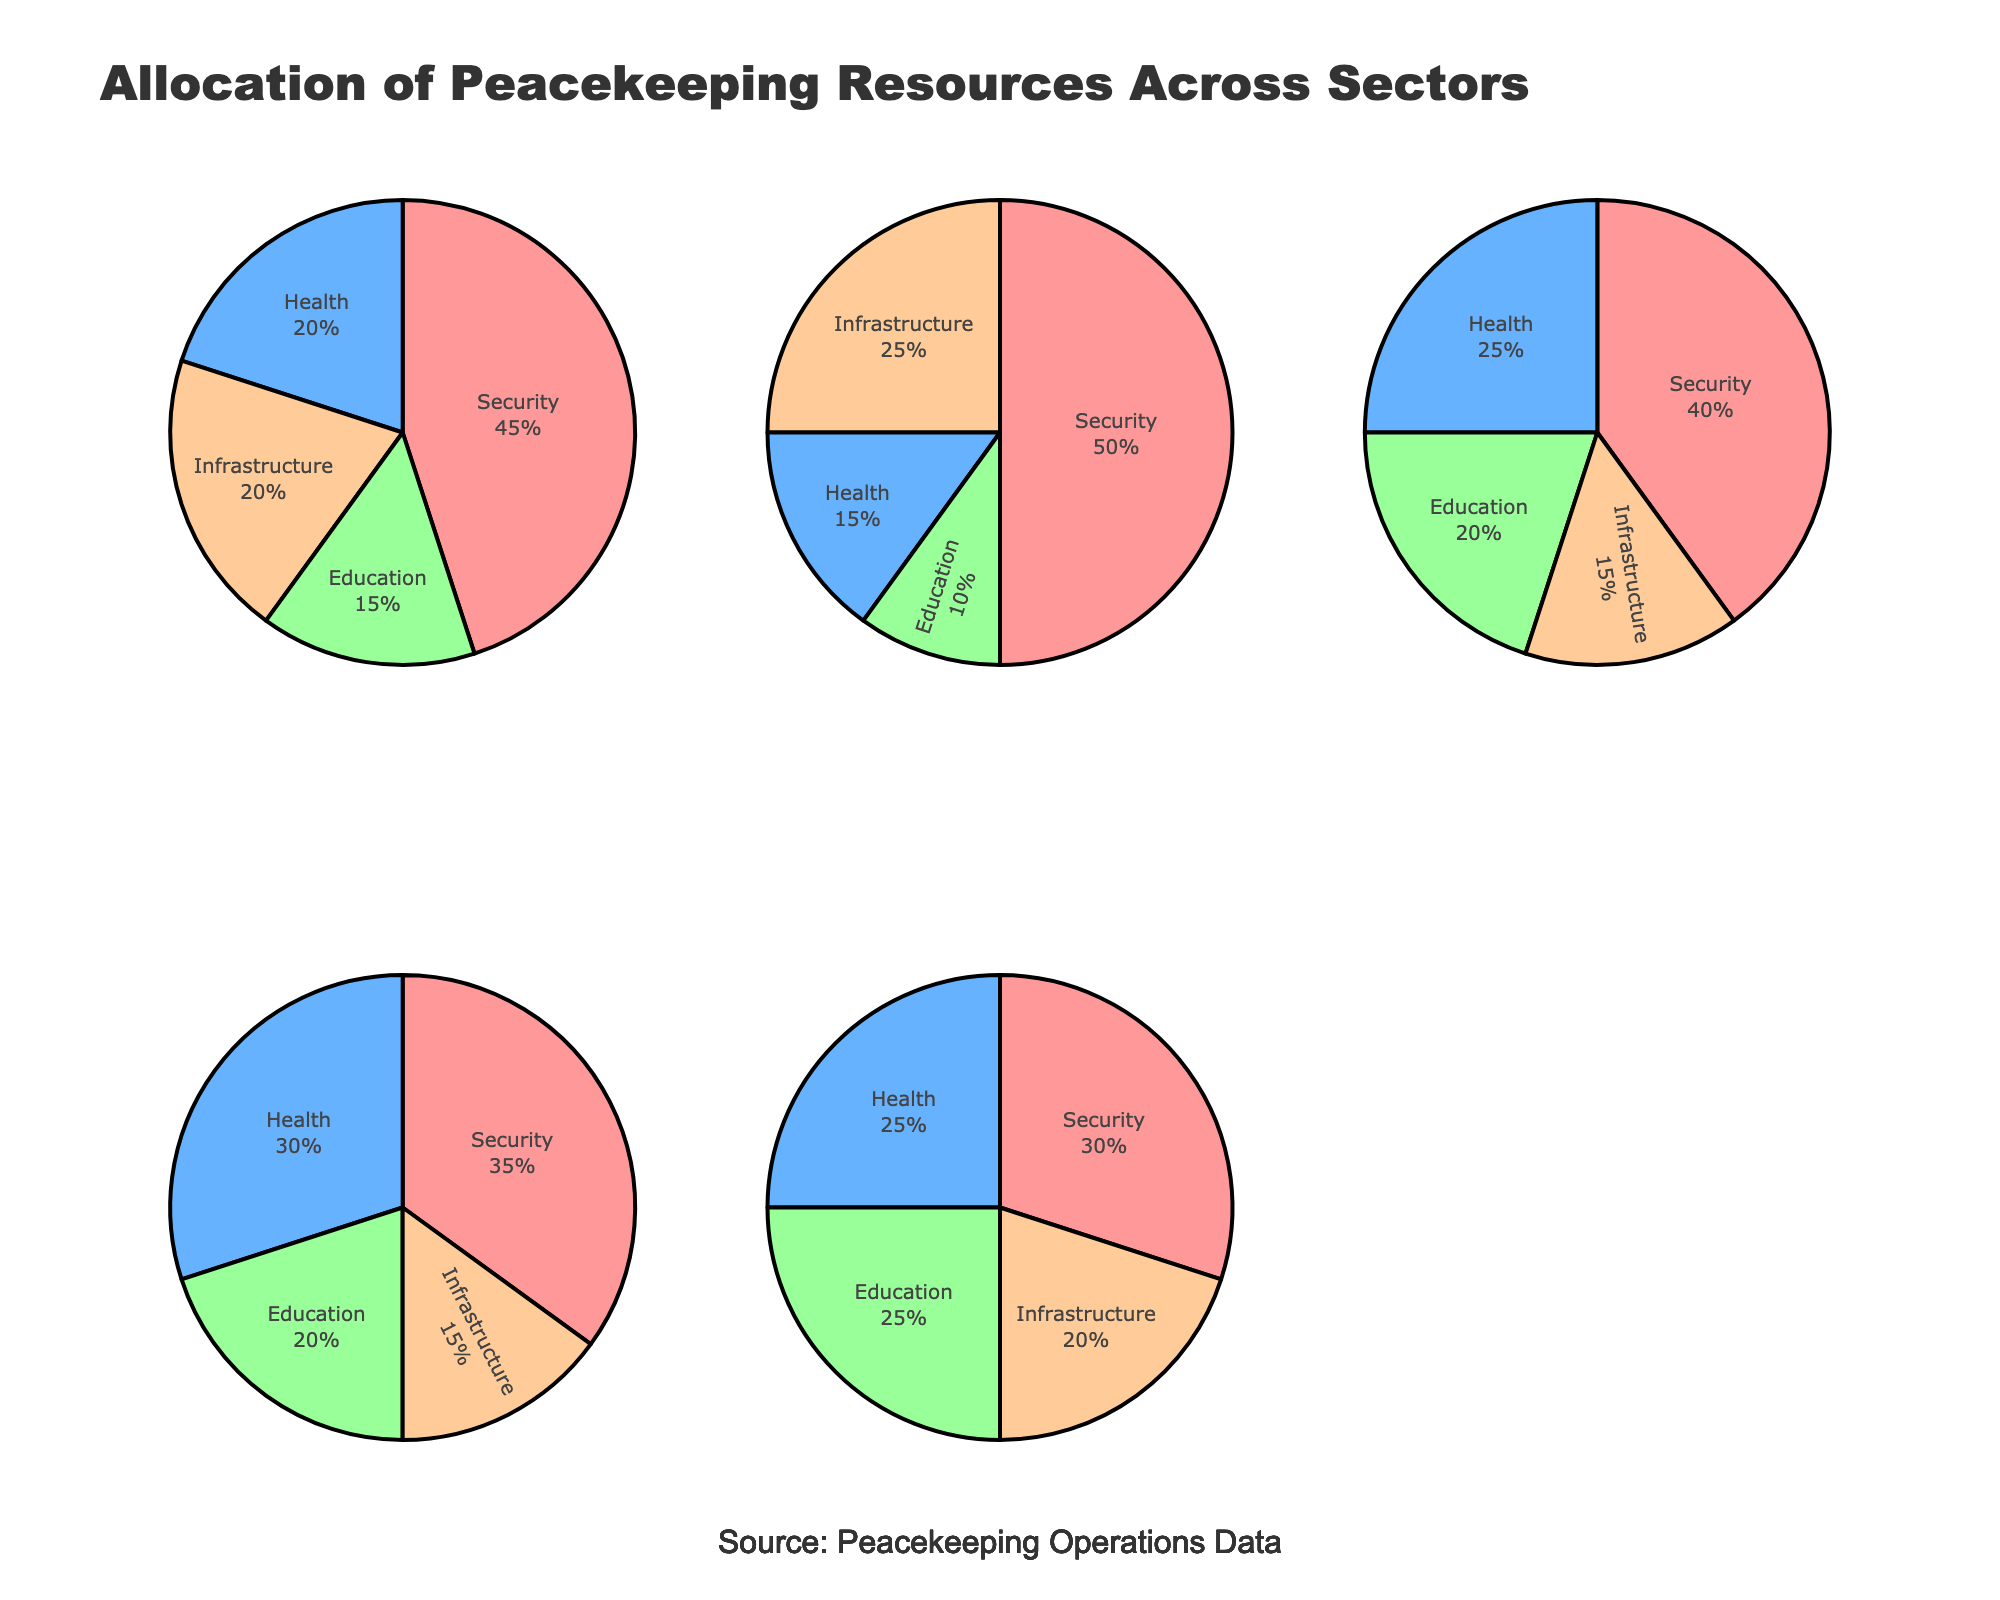What sector has the highest resource allocation in Africa? By observing the pie chart for Africa, the segment labeled "Security" is the largest, indicating it has the highest allocation.
Answer: Security Which region allocates the most resources to health? By examining all the pie charts, Central America's health sector occupies the largest segment among all regions.
Answer: Central America What is the combined percentage of resources allocated to education and infrastructure in Eastern Europe? In Eastern Europe, education is 25% and infrastructure is 20%. Adding these together gives 25% + 20% = 45%.
Answer: 45% Which region allocates fewer resources to security, Central America or Southeast Asia? By comparing the pie charts for Central America and Southeast Asia, Southeast Asia allocates 40% to security while Central America allocates 35%. Therefore, Central America allocates fewer resources to security.
Answer: Central America Rank the regions by the percentage of resources allocated to security from highest to lowest. Looking at the pie charts, the percentages for security are: Middle East (50%), Africa (45%), Southeast Asia (40%), Central America (35%), Eastern Europe (30%).
Answer: Middle East, Africa, Southeast Asia, Central America, Eastern Europe What percentage of resources does Southeast Asia allocate to non-education sectors combined? Southeast Asia allocates 20% to education. Thus, the allocation to non-education sectors is 100% - 20% = 80%.
Answer: 80% What is the average allocation of resources to infrastructure across all five regions? Infrastructure allocations are: Africa (20%), Middle East (25%), Southeast Asia (15%), Central America (15%), Eastern Europe (20%). The average is (20 + 25 + 15 + 15 + 20) / 5 = 19%.
Answer: 19% In which region is the difference between the allocation to health and to infrastructure the largest? By looking at the pie charts, the differences are: Africa (0%), Middle East (10%), Southeast Asia (10%), Central America (15%), Eastern Europe (5%). Central America has the largest difference.
Answer: Central America Which sector in the Middle East has the smallest allocation of resources? From the Middle East pie chart, education is the smallest segment with 10%.
Answer: Education If the allocation to security in Africa were to increase by 5%, what would be the new percentage of the security sector? Africa's current security allocation is 45%. Increasing by 5% results in 45% + 5% = 50%.
Answer: 50% 